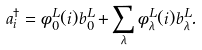Convert formula to latex. <formula><loc_0><loc_0><loc_500><loc_500>a _ { i } ^ { \dagger } = \phi _ { 0 } ^ { L } ( i ) b _ { 0 } ^ { L } + \sum _ { \lambda } \phi _ { \lambda } ^ { L } ( i ) b _ { \lambda } ^ { L } .</formula> 